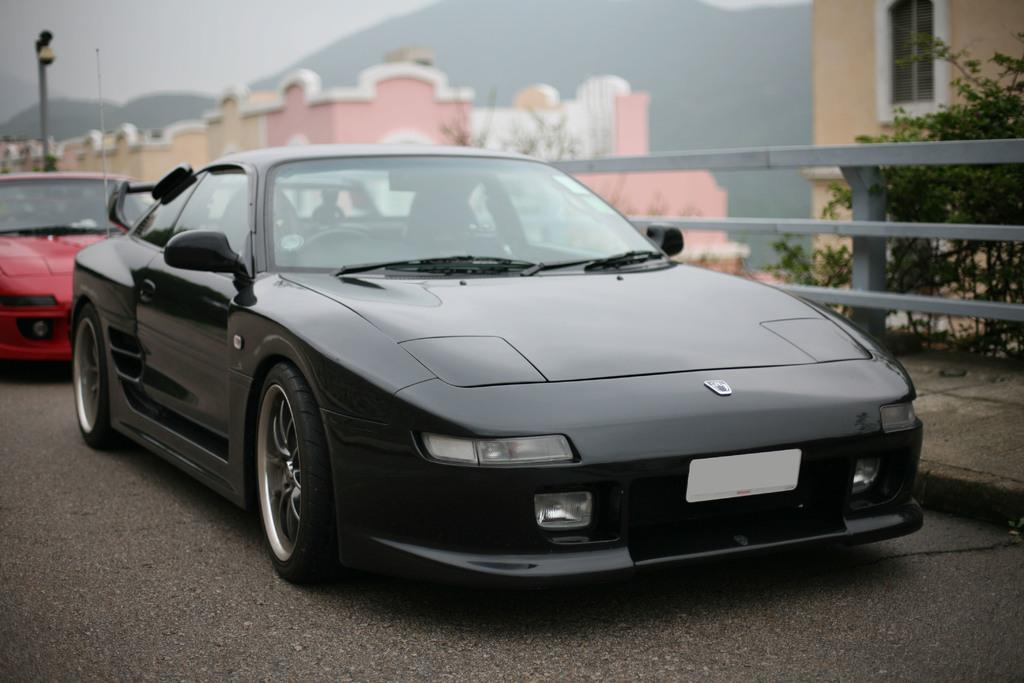How many cars are in the image? There are two cars in the image. What colors are the cars? One car is black, and the other is red. Where are the cars located? The cars are on the road. What else can be seen in the image besides the cars? There are trees, buildings, a pole, mountains, and the sky visible in the image. What type of linen is being used to clean the cars in the image? There is no linen present in the image, and the cars are not being cleaned. What flavor of toothpaste is being advertised on the pole in the image? There is no toothpaste or advertisement present on the pole in the image. 